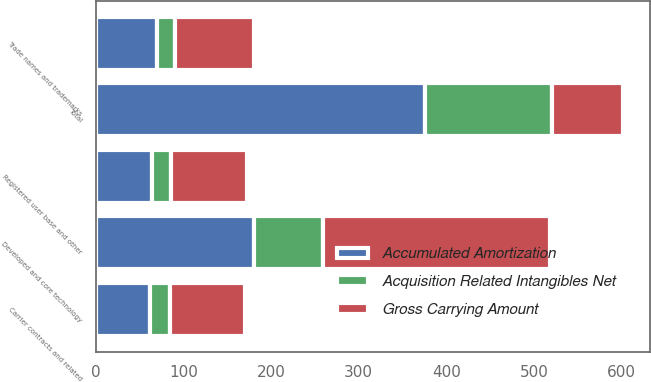Convert chart to OTSL. <chart><loc_0><loc_0><loc_500><loc_500><stacked_bar_chart><ecel><fcel>Developed and core technology<fcel>Trade names and trademarks<fcel>Registered user base and other<fcel>Carrier contracts and related<fcel>Total<nl><fcel>Gross Carrying Amount<fcel>259<fcel>90<fcel>86<fcel>85<fcel>82<nl><fcel>Accumulated Amortization<fcel>180<fcel>70<fcel>64<fcel>62<fcel>376<nl><fcel>Acquisition Related Intangibles Net<fcel>79<fcel>20<fcel>22<fcel>23<fcel>144<nl></chart> 